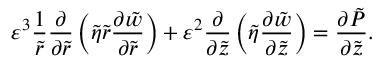<formula> <loc_0><loc_0><loc_500><loc_500>\varepsilon ^ { 3 } \frac { 1 } { \tilde { r } } \frac { \partial } { \partial \tilde { r } } \left ( \tilde { \eta } \tilde { r } \frac { \partial \tilde { w } } { \partial \tilde { r } } \right ) + \varepsilon ^ { 2 } \frac { \partial } { \partial \tilde { z } } \left ( \tilde { \eta } \frac { \partial \tilde { w } } { \partial \tilde { z } } \right ) = \frac { \partial \tilde { P } } { \partial \tilde { z } } .</formula> 